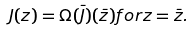<formula> <loc_0><loc_0><loc_500><loc_500>J ( z ) = \Omega ( \bar { J } ) ( \bar { z } ) f o r z = \bar { z } .</formula> 